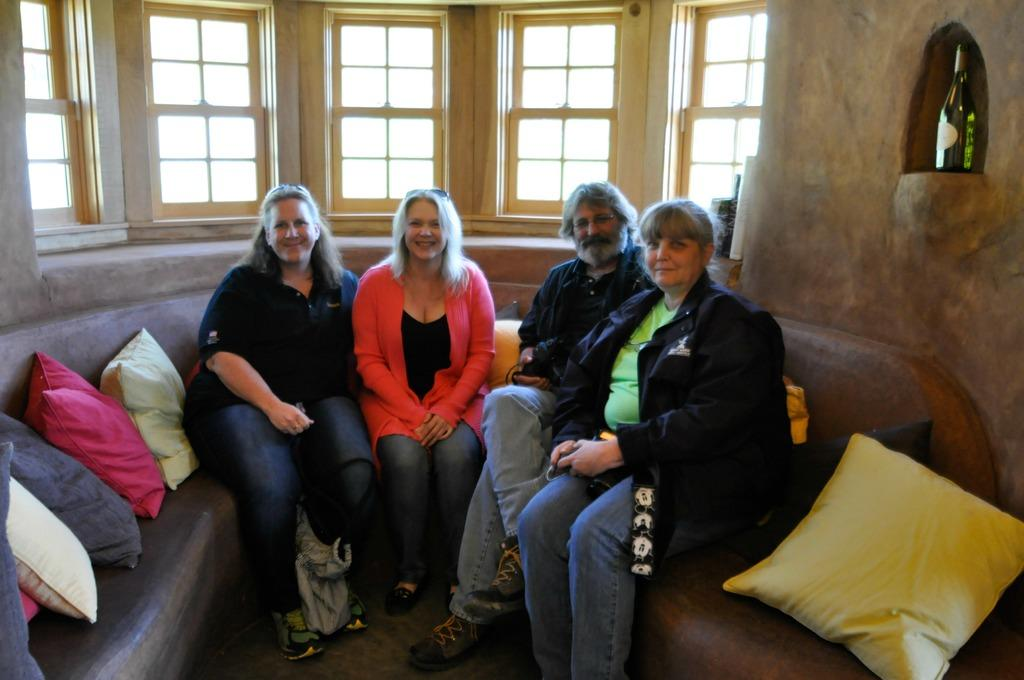How many people are sitting on the sofa in the image? There are four persons sitting on the sofa in the image. What can be seen on the sofa besides the people? Pillows are visible on the sofa. What is visible in the background of the image? There is a wall and windows in the background. What type of rhythm can be heard coming from the knee of the person sitting on the left side of the sofa? There is no indication in the image that any rhythm is being produced, and there is no mention of a knee in the provided facts. 